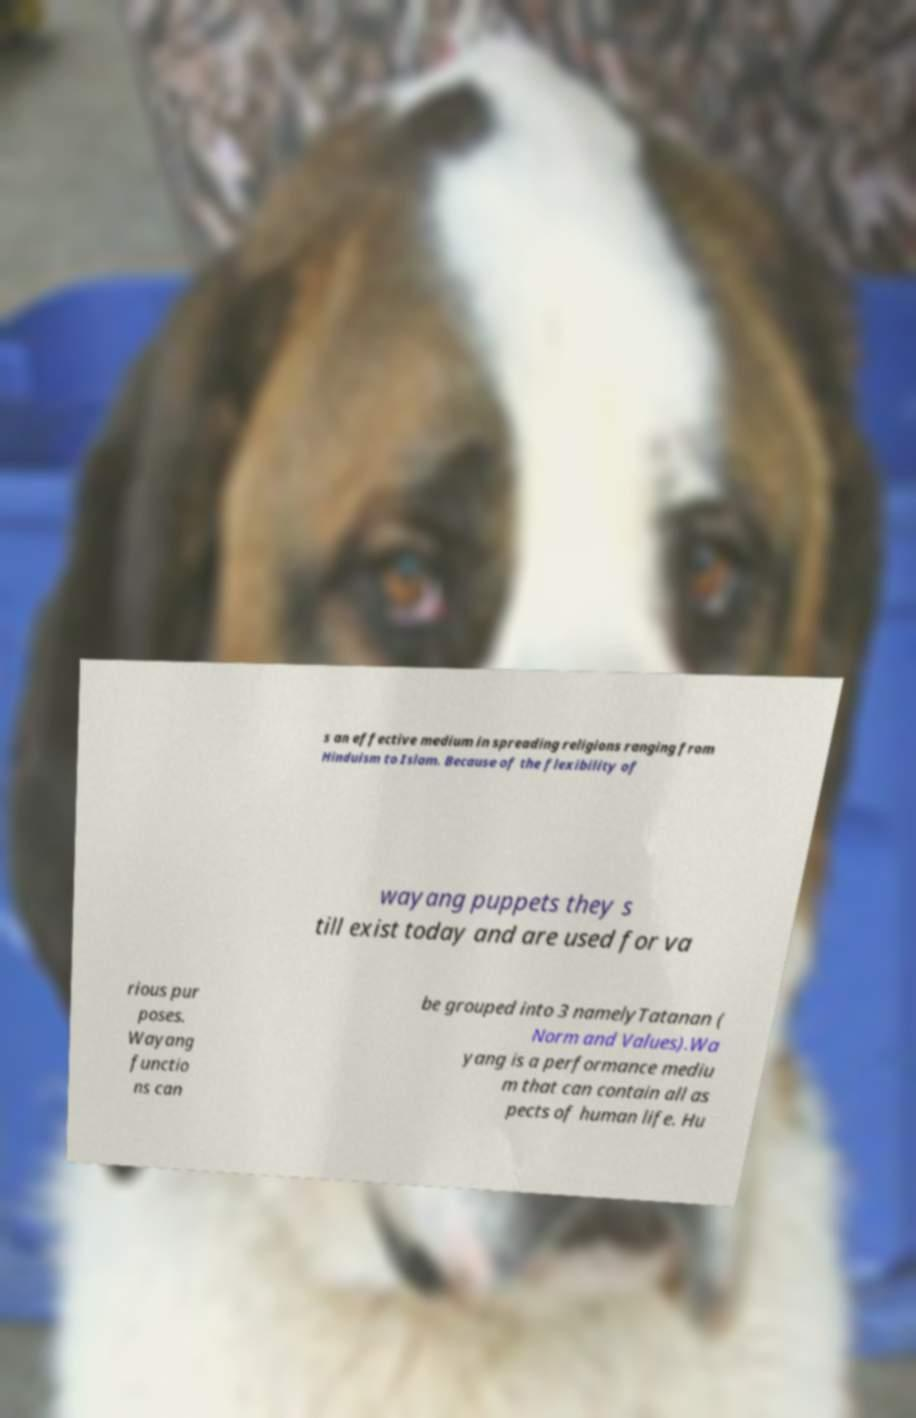Could you extract and type out the text from this image? s an effective medium in spreading religions ranging from Hinduism to Islam. Because of the flexibility of wayang puppets they s till exist today and are used for va rious pur poses. Wayang functio ns can be grouped into 3 namelyTatanan ( Norm and Values).Wa yang is a performance mediu m that can contain all as pects of human life. Hu 